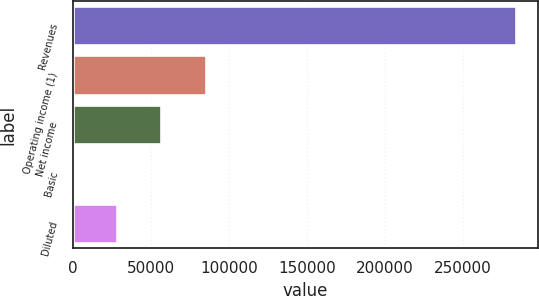<chart> <loc_0><loc_0><loc_500><loc_500><bar_chart><fcel>Revenues<fcel>Operating income (1)<fcel>Net income<fcel>Basic<fcel>Diluted<nl><fcel>284093<fcel>85228<fcel>56818.7<fcel>0.16<fcel>28409.4<nl></chart> 